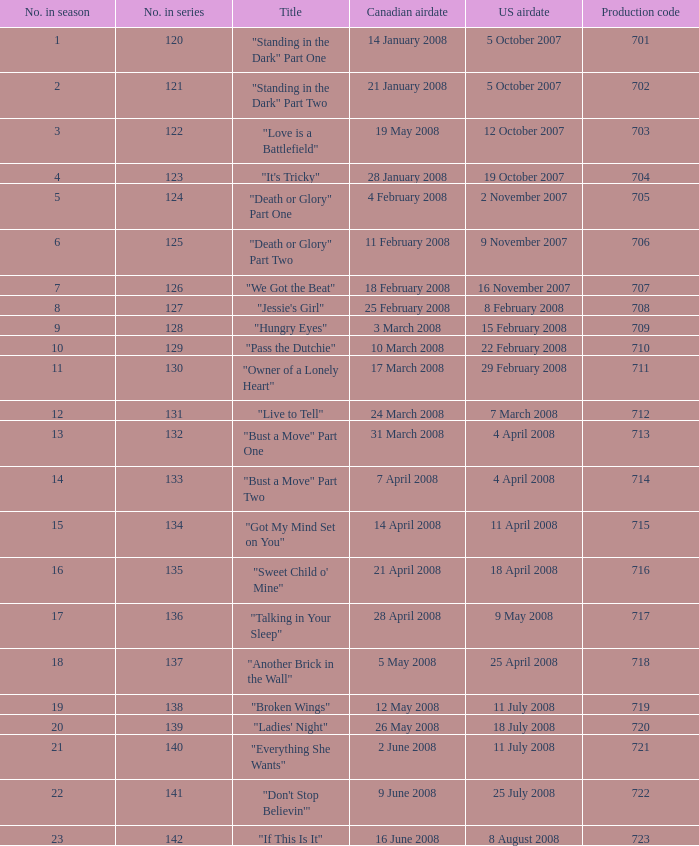For the episode(s) aired in the U.S. on 4 april 2008, what were the names? "Bust a Move" Part One, "Bust a Move" Part Two. 